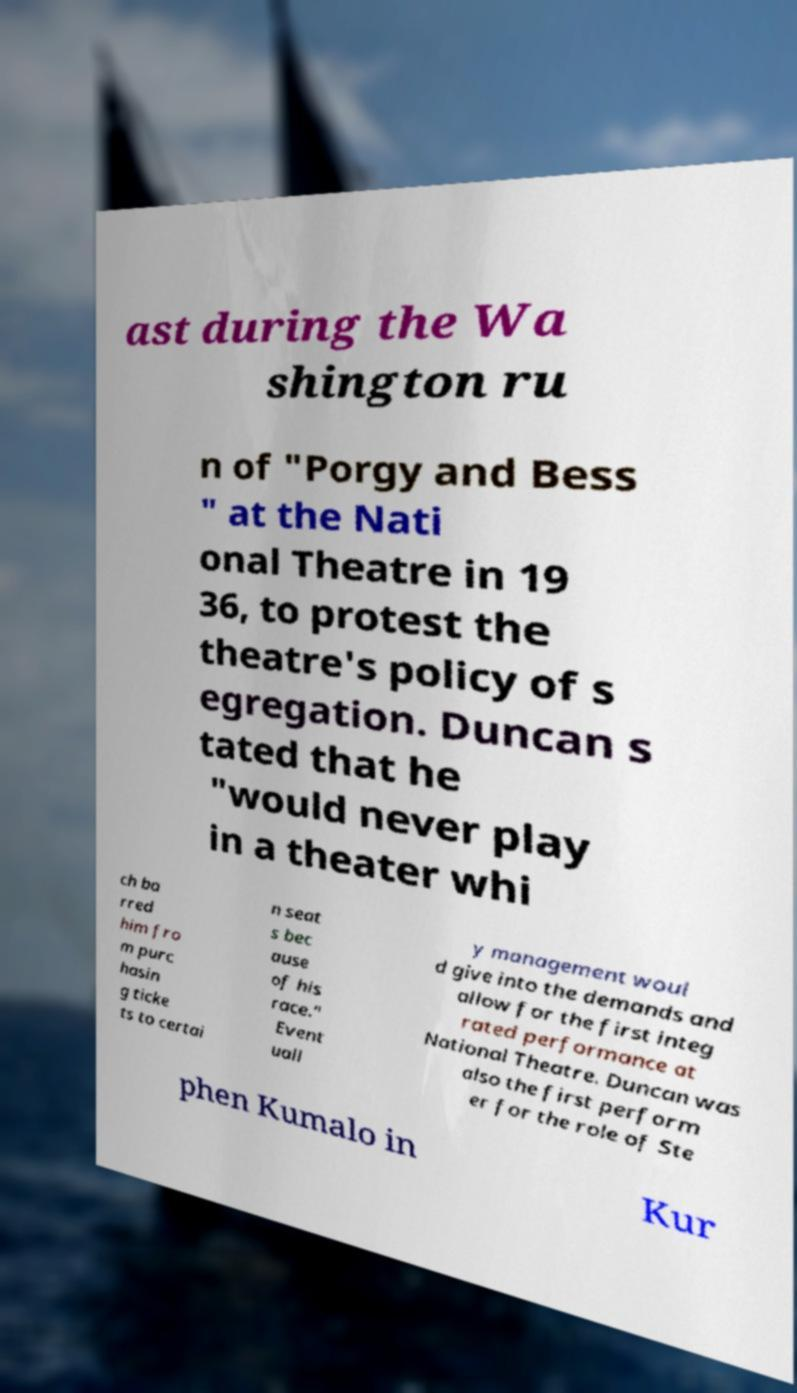Can you read and provide the text displayed in the image?This photo seems to have some interesting text. Can you extract and type it out for me? ast during the Wa shington ru n of "Porgy and Bess " at the Nati onal Theatre in 19 36, to protest the theatre's policy of s egregation. Duncan s tated that he "would never play in a theater whi ch ba rred him fro m purc hasin g ticke ts to certai n seat s bec ause of his race." Event uall y management woul d give into the demands and allow for the first integ rated performance at National Theatre. Duncan was also the first perform er for the role of Ste phen Kumalo in Kur 